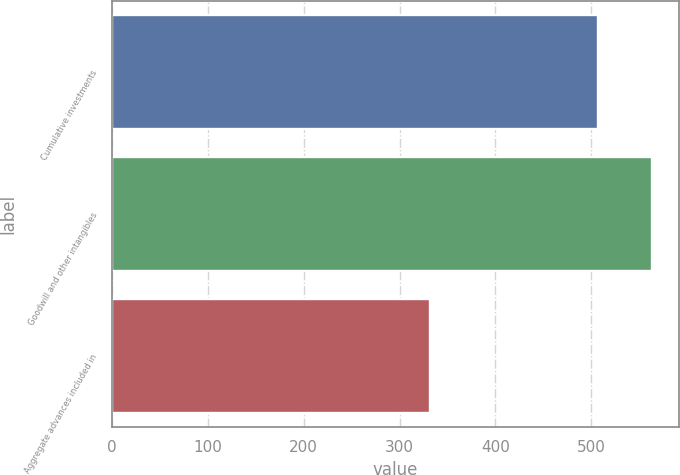Convert chart. <chart><loc_0><loc_0><loc_500><loc_500><bar_chart><fcel>Cumulative investments<fcel>Goodwill and other intangibles<fcel>Aggregate advances included in<nl><fcel>507.5<fcel>563.2<fcel>332<nl></chart> 